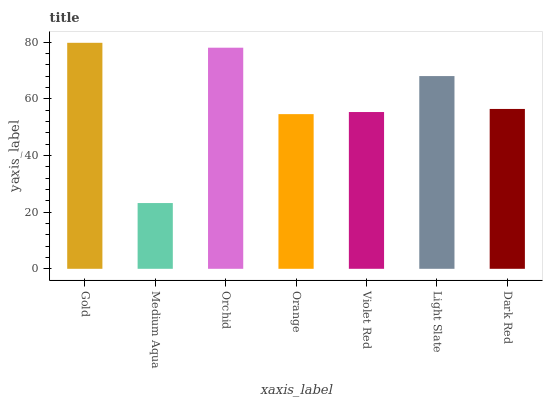Is Medium Aqua the minimum?
Answer yes or no. Yes. Is Gold the maximum?
Answer yes or no. Yes. Is Orchid the minimum?
Answer yes or no. No. Is Orchid the maximum?
Answer yes or no. No. Is Orchid greater than Medium Aqua?
Answer yes or no. Yes. Is Medium Aqua less than Orchid?
Answer yes or no. Yes. Is Medium Aqua greater than Orchid?
Answer yes or no. No. Is Orchid less than Medium Aqua?
Answer yes or no. No. Is Dark Red the high median?
Answer yes or no. Yes. Is Dark Red the low median?
Answer yes or no. Yes. Is Medium Aqua the high median?
Answer yes or no. No. Is Orange the low median?
Answer yes or no. No. 